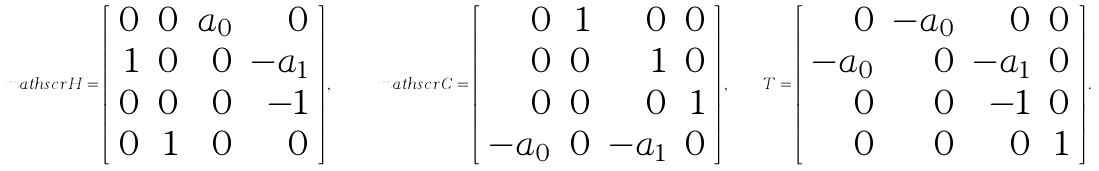<formula> <loc_0><loc_0><loc_500><loc_500>\ m a t h s c r { H } = \left [ \begin{array} { r r r r } 0 & 0 & a _ { 0 } & 0 \\ 1 & 0 & 0 & - a _ { 1 } \\ 0 & 0 & 0 & - 1 \\ 0 & 1 & 0 & 0 \end{array} \right ] , \quad \ m a t h s c r { C } = \left [ \begin{array} { r r r r } 0 & 1 & 0 & 0 \\ 0 & 0 & 1 & 0 \\ 0 & 0 & 0 & 1 \\ - a _ { 0 } & 0 & - a _ { 1 } & 0 \end{array} \right ] , \quad T = \left [ \begin{array} { r r r r } 0 & - a _ { 0 } & 0 & 0 \\ - a _ { 0 } & 0 & - a _ { 1 } & 0 \\ 0 & 0 & - 1 & 0 \\ 0 & 0 & 0 & 1 \end{array} \right ] .</formula> 